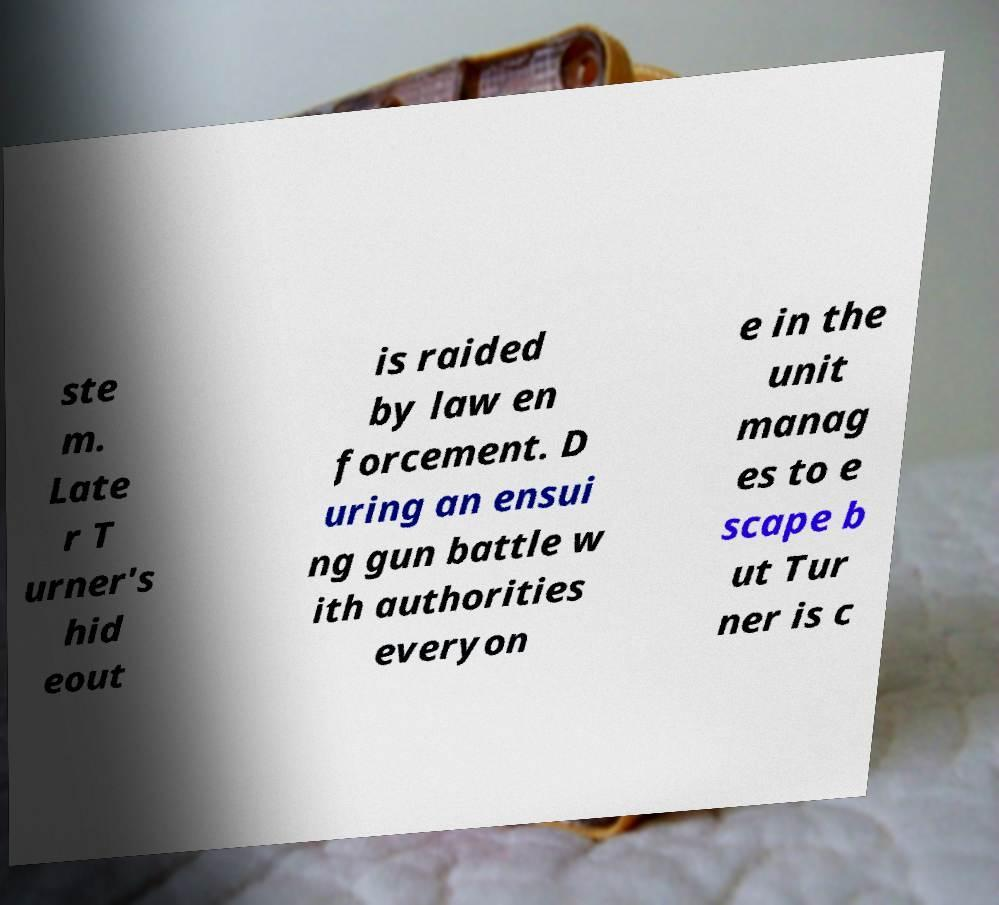Please identify and transcribe the text found in this image. ste m. Late r T urner's hid eout is raided by law en forcement. D uring an ensui ng gun battle w ith authorities everyon e in the unit manag es to e scape b ut Tur ner is c 